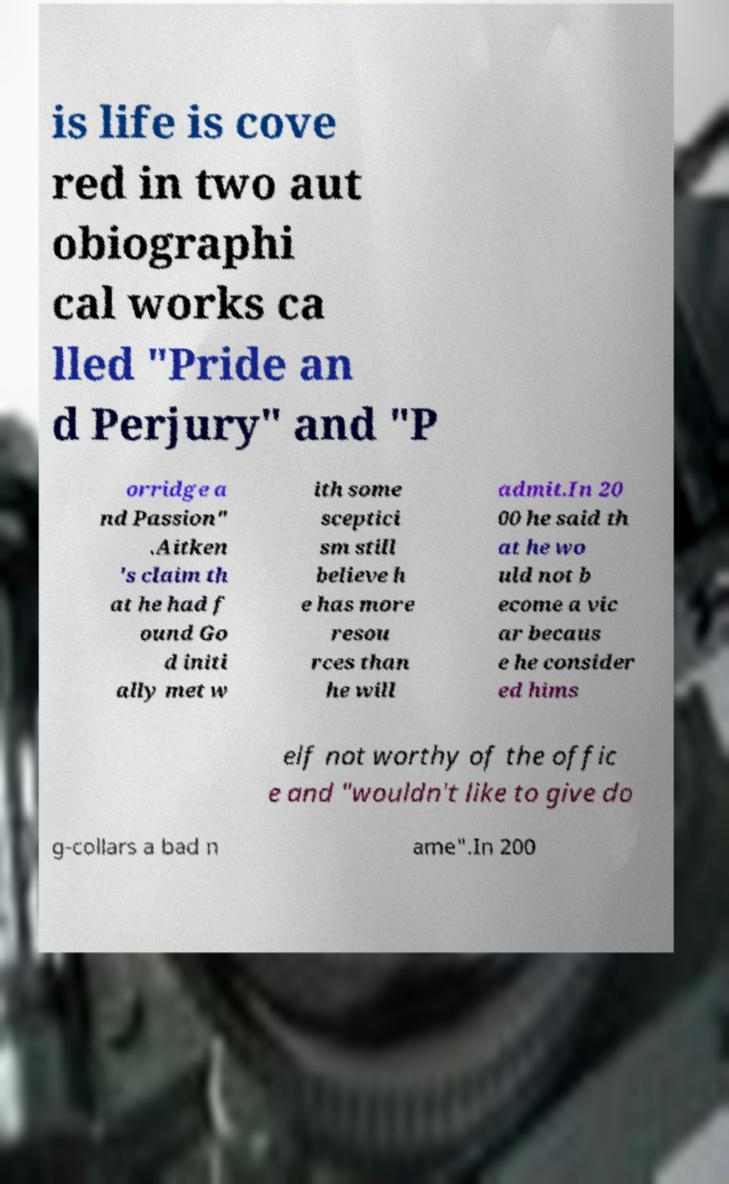Can you accurately transcribe the text from the provided image for me? is life is cove red in two aut obiographi cal works ca lled "Pride an d Perjury" and "P orridge a nd Passion" .Aitken 's claim th at he had f ound Go d initi ally met w ith some sceptici sm still believe h e has more resou rces than he will admit.In 20 00 he said th at he wo uld not b ecome a vic ar becaus e he consider ed hims elf not worthy of the offic e and "wouldn't like to give do g-collars a bad n ame".In 200 